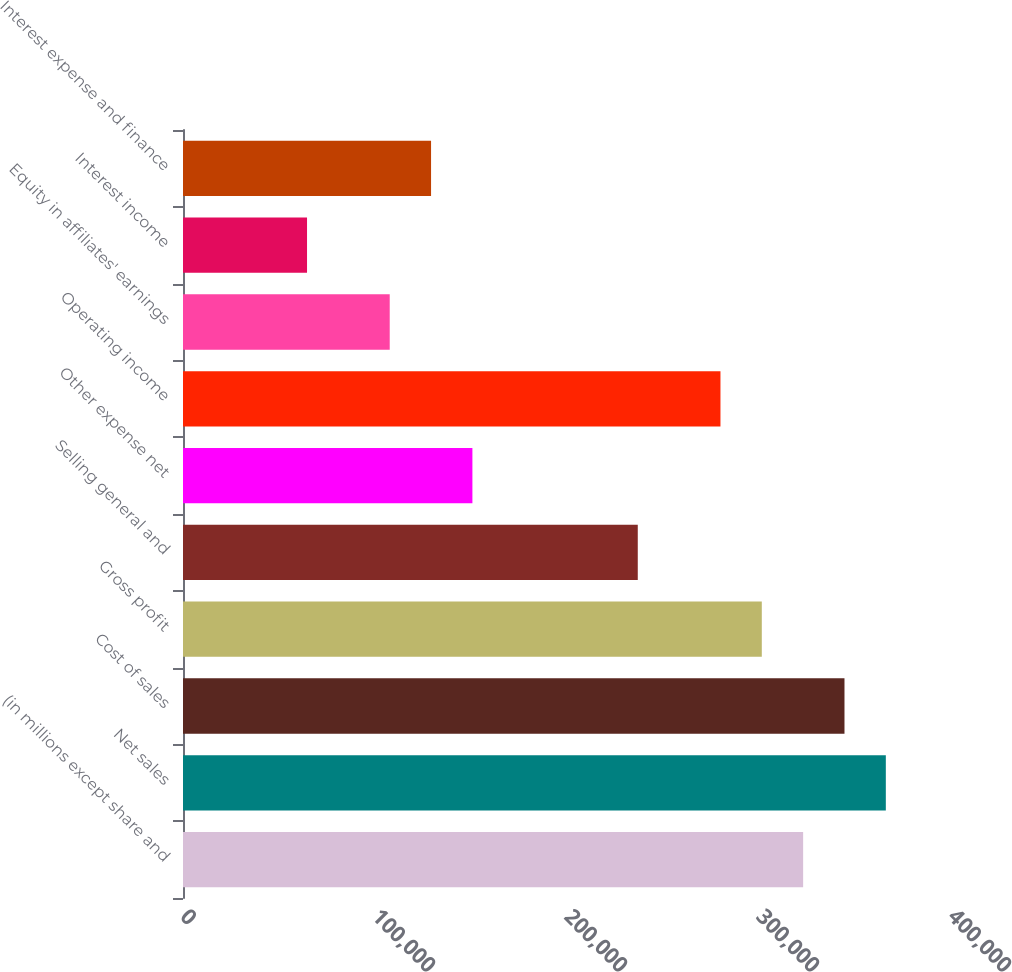Convert chart to OTSL. <chart><loc_0><loc_0><loc_500><loc_500><bar_chart><fcel>(in millions except share and<fcel>Net sales<fcel>Cost of sales<fcel>Gross profit<fcel>Selling general and<fcel>Other expense net<fcel>Operating income<fcel>Equity in affiliates' earnings<fcel>Interest income<fcel>Interest expense and finance<nl><fcel>322991<fcel>366056<fcel>344523<fcel>301458<fcel>236860<fcel>150730<fcel>279926<fcel>107665<fcel>64600.3<fcel>129198<nl></chart> 